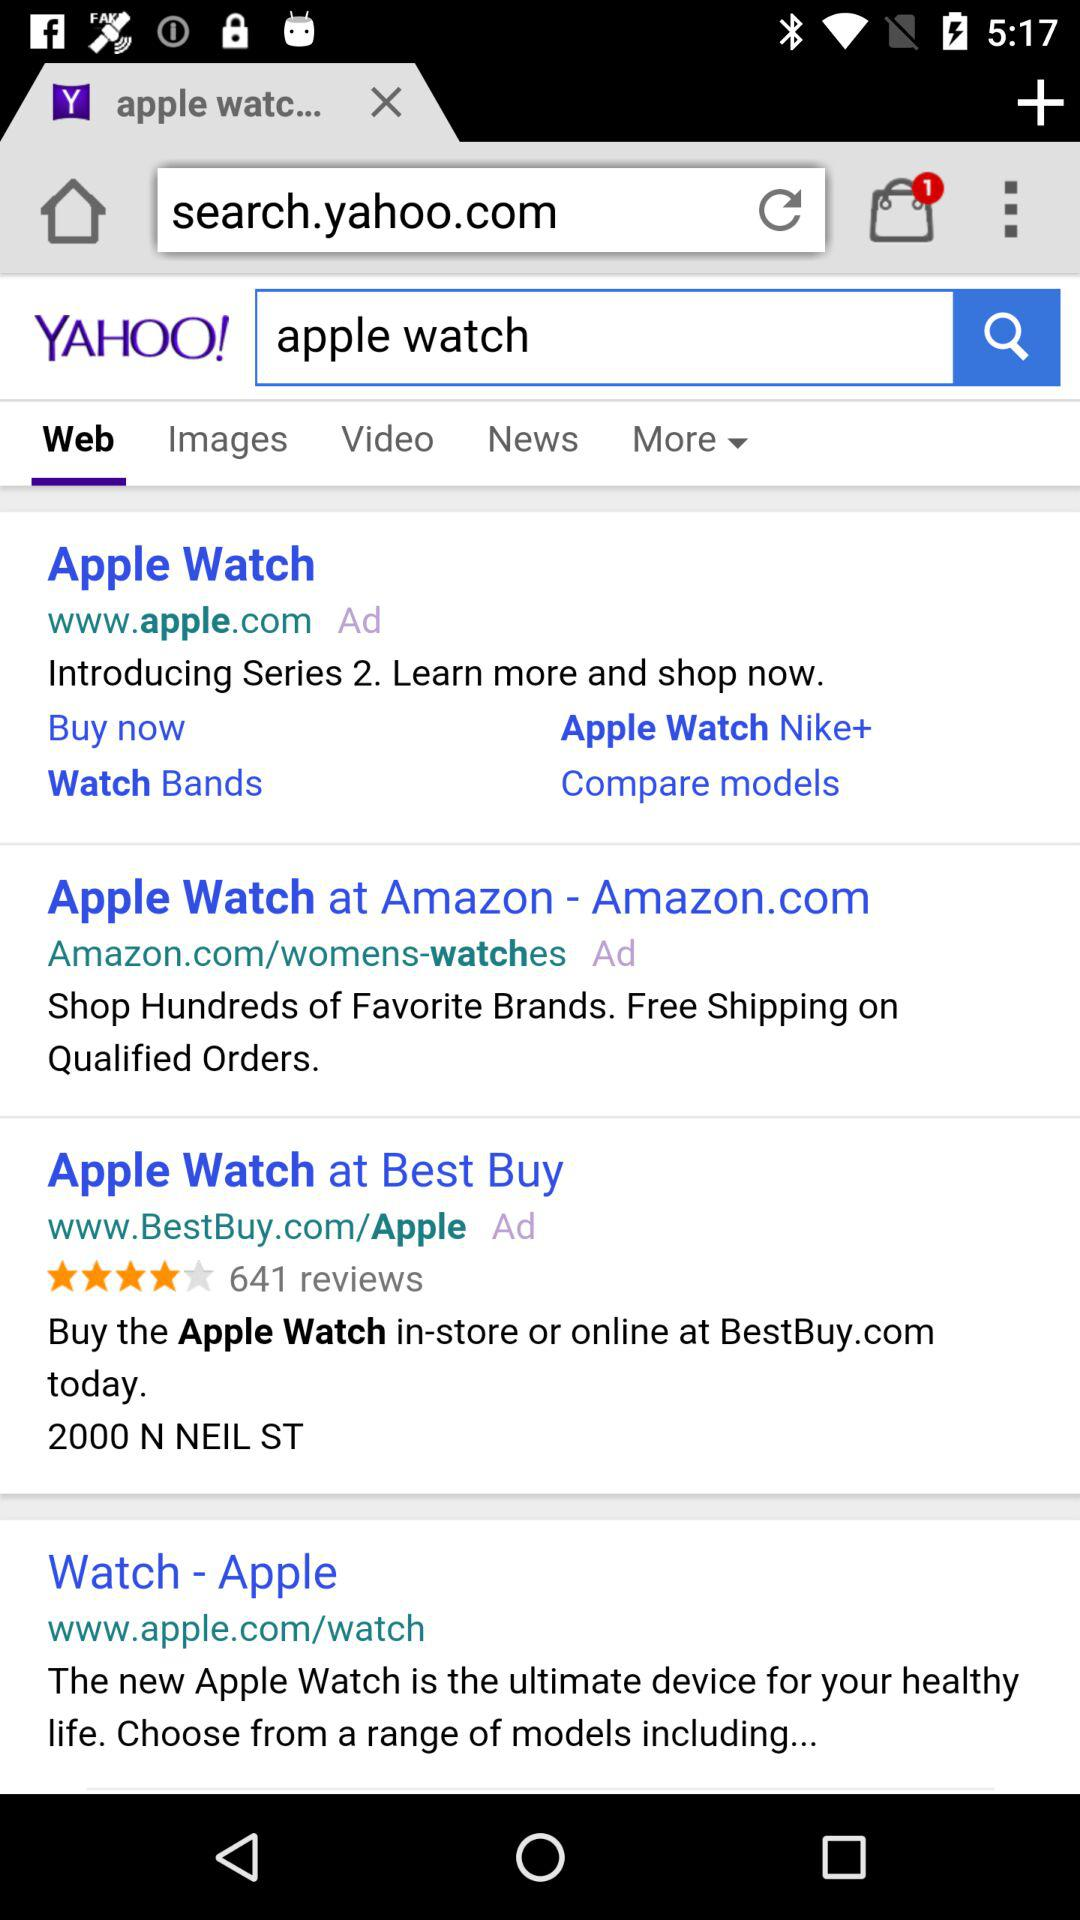How many reviews are on the www.BestBuy.com website? There are 641 reviews. 